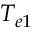<formula> <loc_0><loc_0><loc_500><loc_500>T _ { e 1 }</formula> 